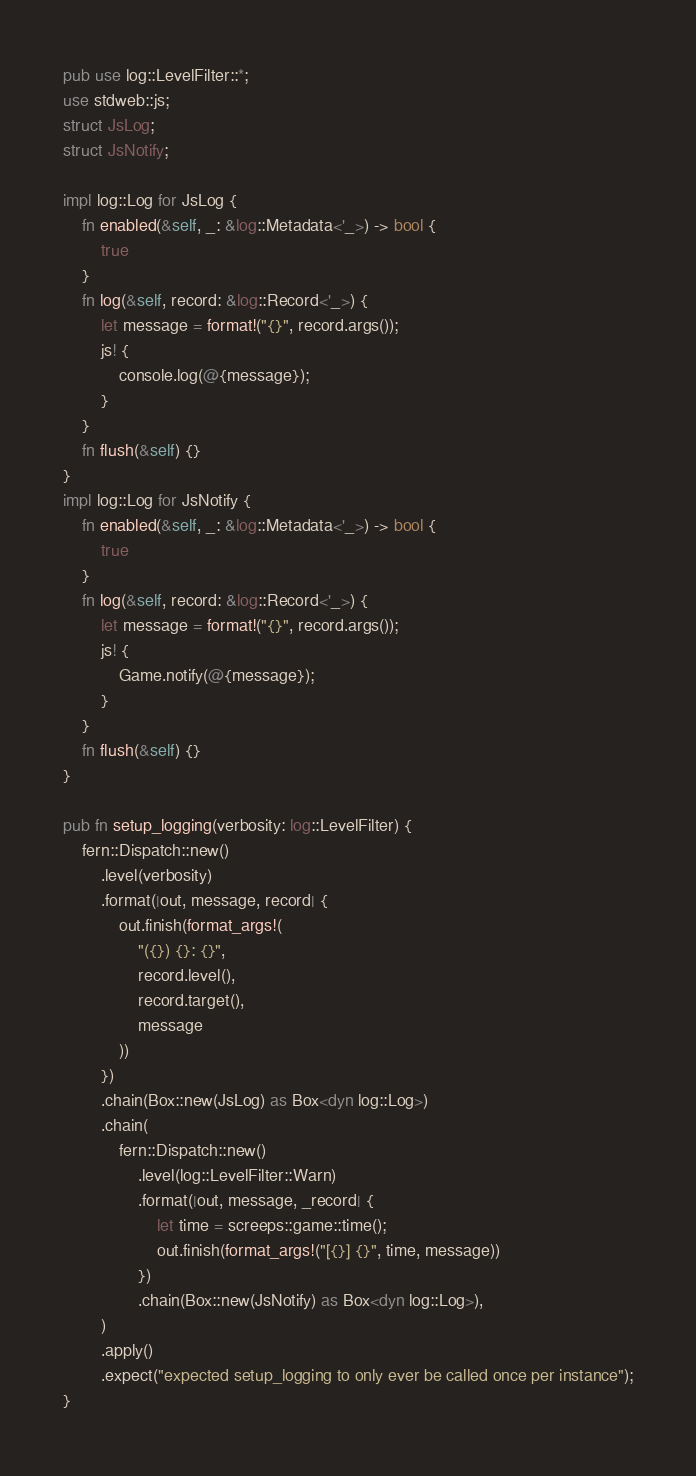<code> <loc_0><loc_0><loc_500><loc_500><_Rust_>pub use log::LevelFilter::*;
use stdweb::js;
struct JsLog;
struct JsNotify;

impl log::Log for JsLog {
    fn enabled(&self, _: &log::Metadata<'_>) -> bool {
        true
    }
    fn log(&self, record: &log::Record<'_>) {
        let message = format!("{}", record.args());
        js! {
            console.log(@{message});
        }
    }
    fn flush(&self) {}
}
impl log::Log for JsNotify {
    fn enabled(&self, _: &log::Metadata<'_>) -> bool {
        true
    }
    fn log(&self, record: &log::Record<'_>) {
        let message = format!("{}", record.args());
        js! {
            Game.notify(@{message});
        }
    }
    fn flush(&self) {}
}

pub fn setup_logging(verbosity: log::LevelFilter) {
    fern::Dispatch::new()
        .level(verbosity)
        .format(|out, message, record| {
            out.finish(format_args!(
                "({}) {}: {}",
                record.level(),
                record.target(),
                message
            ))
        })
        .chain(Box::new(JsLog) as Box<dyn log::Log>)
        .chain(
            fern::Dispatch::new()
                .level(log::LevelFilter::Warn)
                .format(|out, message, _record| {
                    let time = screeps::game::time();
                    out.finish(format_args!("[{}] {}", time, message))
                })
                .chain(Box::new(JsNotify) as Box<dyn log::Log>),
        )
        .apply()
        .expect("expected setup_logging to only ever be called once per instance");
}
</code> 